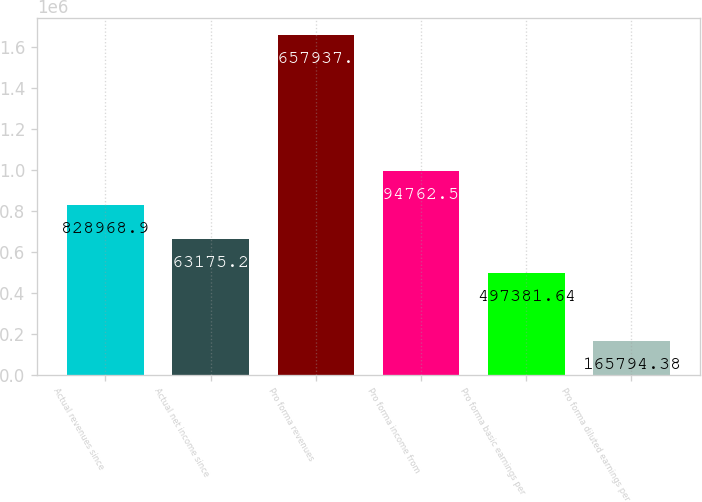Convert chart. <chart><loc_0><loc_0><loc_500><loc_500><bar_chart><fcel>Actual revenues since<fcel>Actual net income since<fcel>Pro forma revenues<fcel>Pro forma income from<fcel>Pro forma basic earnings per<fcel>Pro forma diluted earnings per<nl><fcel>828969<fcel>663175<fcel>1.65794e+06<fcel>994763<fcel>497382<fcel>165794<nl></chart> 